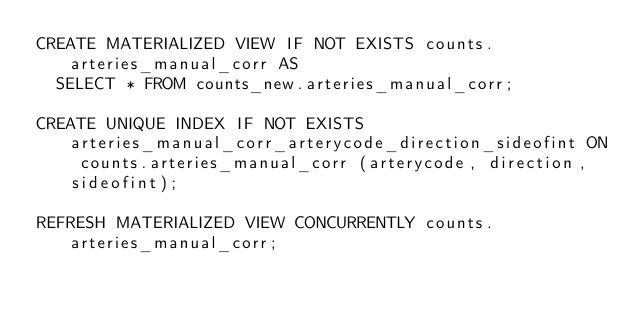Convert code to text. <code><loc_0><loc_0><loc_500><loc_500><_SQL_>CREATE MATERIALIZED VIEW IF NOT EXISTS counts.arteries_manual_corr AS
  SELECT * FROM counts_new.arteries_manual_corr;

CREATE UNIQUE INDEX IF NOT EXISTS arteries_manual_corr_arterycode_direction_sideofint ON counts.arteries_manual_corr (arterycode, direction, sideofint);

REFRESH MATERIALIZED VIEW CONCURRENTLY counts.arteries_manual_corr;
</code> 